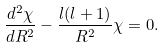<formula> <loc_0><loc_0><loc_500><loc_500>\frac { d ^ { 2 } \chi } { d R ^ { 2 } } - \frac { l ( l + 1 ) } { R ^ { 2 } } \chi = 0 .</formula> 